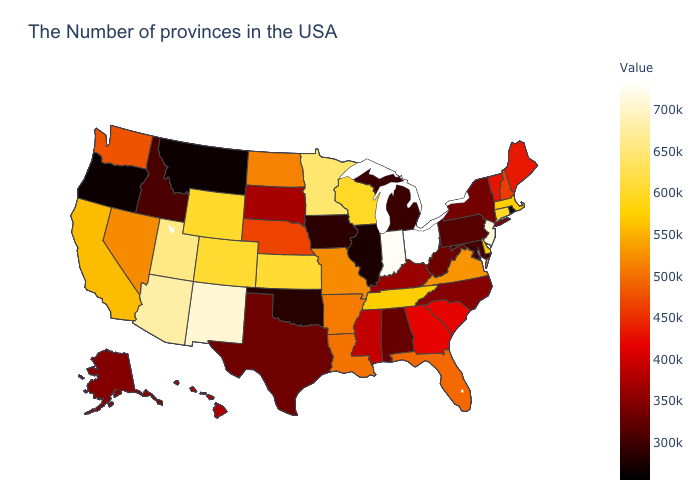Which states have the highest value in the USA?
Keep it brief. Ohio. Does Delaware have the highest value in the South?
Write a very short answer. Yes. Does New York have the highest value in the USA?
Be succinct. No. 